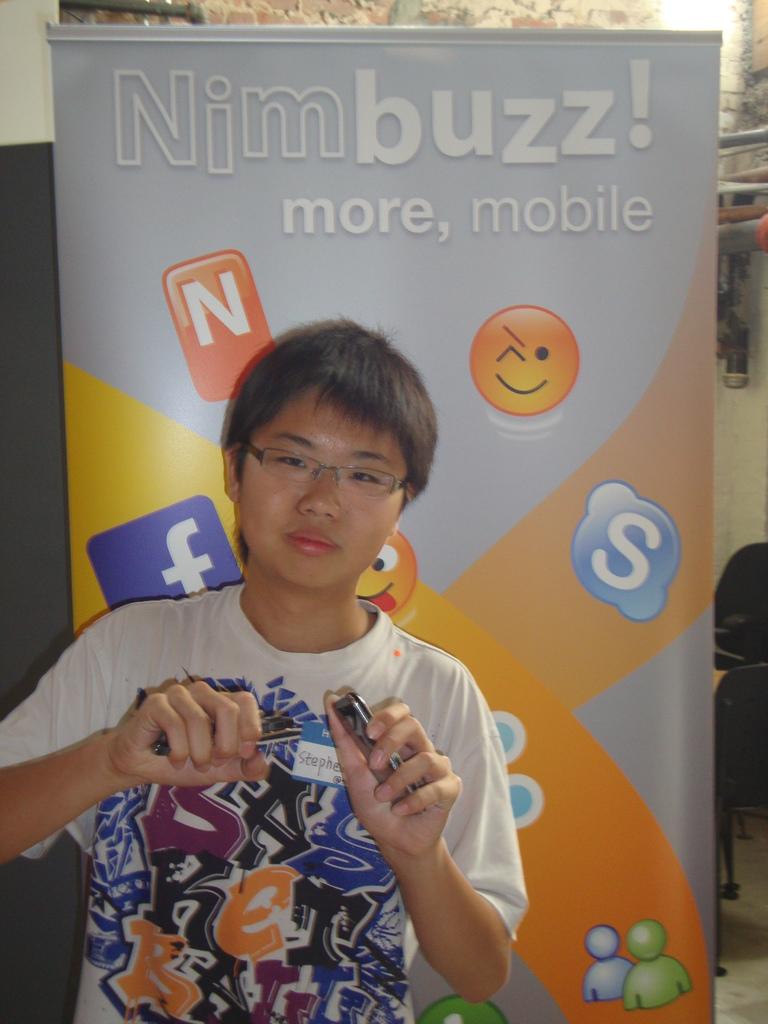What kind of buzz is it?
Your response must be concise. Nim. Is this for mobile?
Offer a very short reply. Yes. 